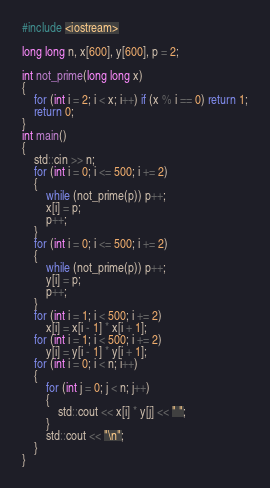<code> <loc_0><loc_0><loc_500><loc_500><_C++_>#include <iostream>

long long n, x[600], y[600], p = 2;

int not_prime(long long x)
{
	for (int i = 2; i < x; i++) if (x % i == 0) return 1;
	return 0;
}
int main()
{
	std::cin >> n;
	for (int i = 0; i <= 500; i += 2)
	{
		while (not_prime(p)) p++;
		x[i] = p;
		p++;
	}
	for (int i = 0; i <= 500; i += 2)
	{
		while (not_prime(p)) p++;
		y[i] = p;
		p++;
	}
	for (int i = 1; i < 500; i += 2)
	    x[i] = x[i - 1] * x[i + 1];
	for (int i = 1; i < 500; i += 2)
	    y[i] = y[i - 1] * y[i + 1];
	for (int i = 0; i < n; i++)
	{
		for (int j = 0; j < n; j++)
		{
			std::cout << x[i] * y[j] << " ";
		}
		std::cout << "\n";
	}
}</code> 